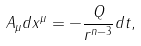Convert formula to latex. <formula><loc_0><loc_0><loc_500><loc_500>A _ { \mu } d x ^ { \mu } = - \frac { Q } { r ^ { n - 3 } } d t ,</formula> 